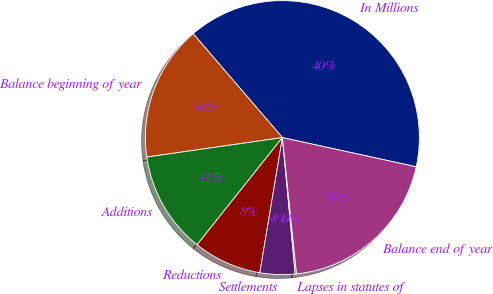<chart> <loc_0><loc_0><loc_500><loc_500><pie_chart><fcel>In Millions<fcel>Balance beginning of year<fcel>Additions<fcel>Reductions<fcel>Settlements<fcel>Lapses in statutes of<fcel>Balance end of year<nl><fcel>39.71%<fcel>15.98%<fcel>12.03%<fcel>8.07%<fcel>4.12%<fcel>0.16%<fcel>19.94%<nl></chart> 